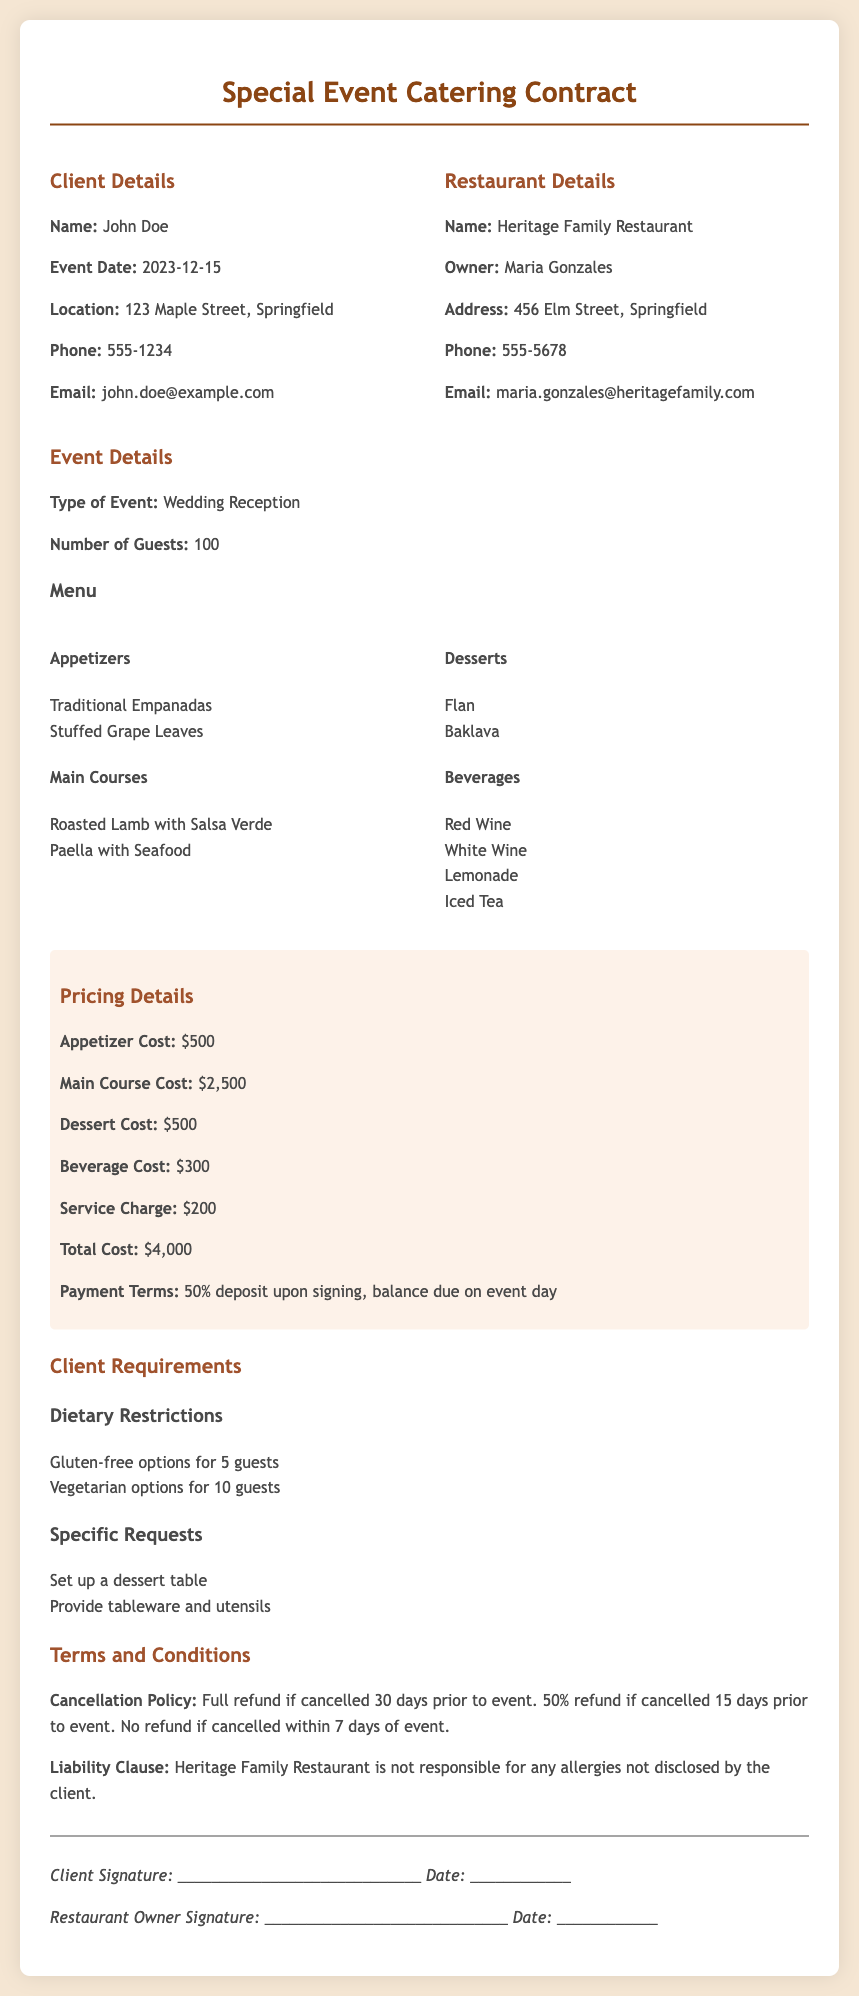What is the date of the event? The date of the event is specified in the document under "Event Date."
Answer: 2023-12-15 Who is the restaurant owner? The owner of the restaurant is clearly listed in the "Restaurant Details" section.
Answer: Maria Gonzales What is the total cost for the catering service? The total cost is found in the "Pricing Details" section of the document.
Answer: $4,000 How many vegetarian options are required? The number of vegetarian options is outlined in the "Dietary Restrictions" part under "Client Requirements."
Answer: 10 What specific request is made regarding desserts? The specific request related to desserts is listed in the "Specific Requests" section under "Client Requirements."
Answer: Set up a dessert table What is the cancellation policy if cancelled within 7 days? The cancellation policy is detailed under "Terms and Conditions."
Answer: No refund if cancelled within 7 days of event What is the service charge amount? The service charge amount is specified in the "Pricing Details" section.
Answer: $200 How many guests are expected for the event? The expected number of guests is stated in the "Event Details" section.
Answer: 100 What is included in the beverage selection? The beverages offered are listed under "Beverages" in the "Event Details" section.
Answer: Red Wine, White Wine, Lemonade, Iced Tea 